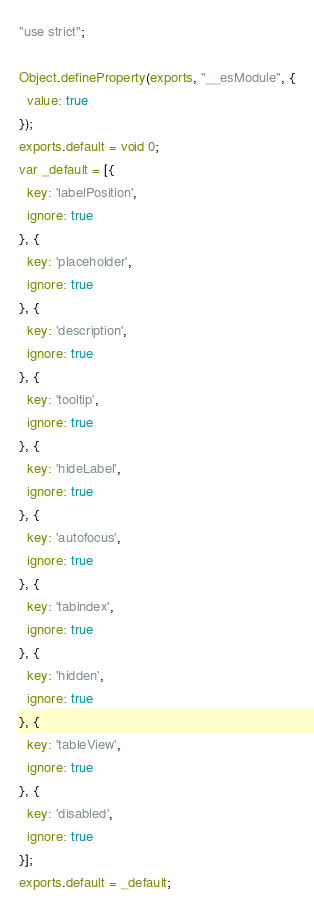Convert code to text. <code><loc_0><loc_0><loc_500><loc_500><_JavaScript_>"use strict";

Object.defineProperty(exports, "__esModule", {
  value: true
});
exports.default = void 0;
var _default = [{
  key: 'labelPosition',
  ignore: true
}, {
  key: 'placeholder',
  ignore: true
}, {
  key: 'description',
  ignore: true
}, {
  key: 'tooltip',
  ignore: true
}, {
  key: 'hideLabel',
  ignore: true
}, {
  key: 'autofocus',
  ignore: true
}, {
  key: 'tabindex',
  ignore: true
}, {
  key: 'hidden',
  ignore: true
}, {
  key: 'tableView',
  ignore: true
}, {
  key: 'disabled',
  ignore: true
}];
exports.default = _default;</code> 